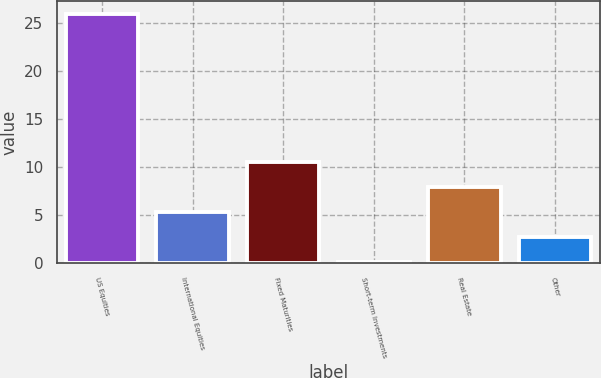Convert chart. <chart><loc_0><loc_0><loc_500><loc_500><bar_chart><fcel>US Equities<fcel>International Equities<fcel>Fixed Maturities<fcel>Short-term Investments<fcel>Real Estate<fcel>Other<nl><fcel>26<fcel>5.33<fcel>10.51<fcel>0.15<fcel>7.92<fcel>2.74<nl></chart> 